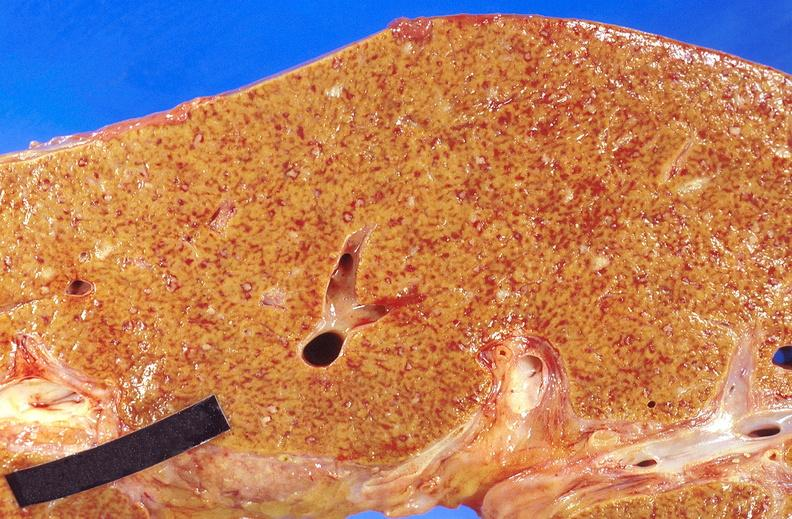does this image show liver, miliary tuberculosis?
Answer the question using a single word or phrase. Yes 